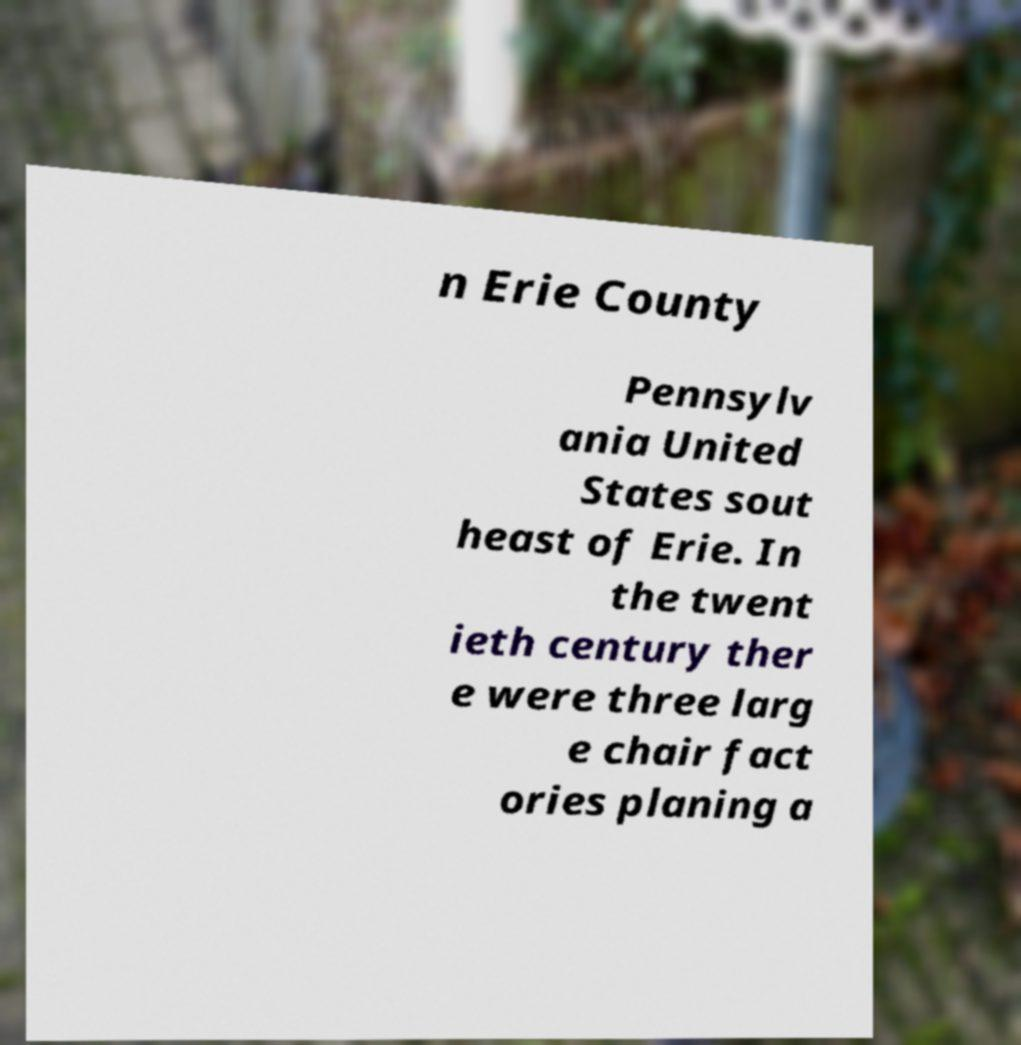There's text embedded in this image that I need extracted. Can you transcribe it verbatim? n Erie County Pennsylv ania United States sout heast of Erie. In the twent ieth century ther e were three larg e chair fact ories planing a 